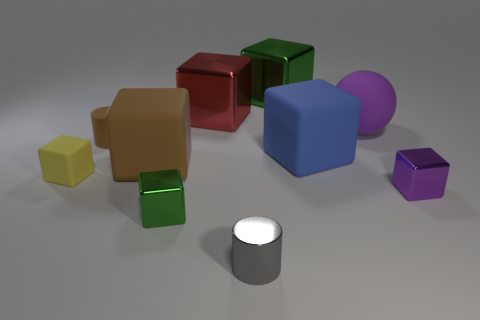What is the positioning of the green object in relation to the red cube? The green cube is positioned to the immediate left of the red cube and slightly in front of it based on the perspective in the image. 